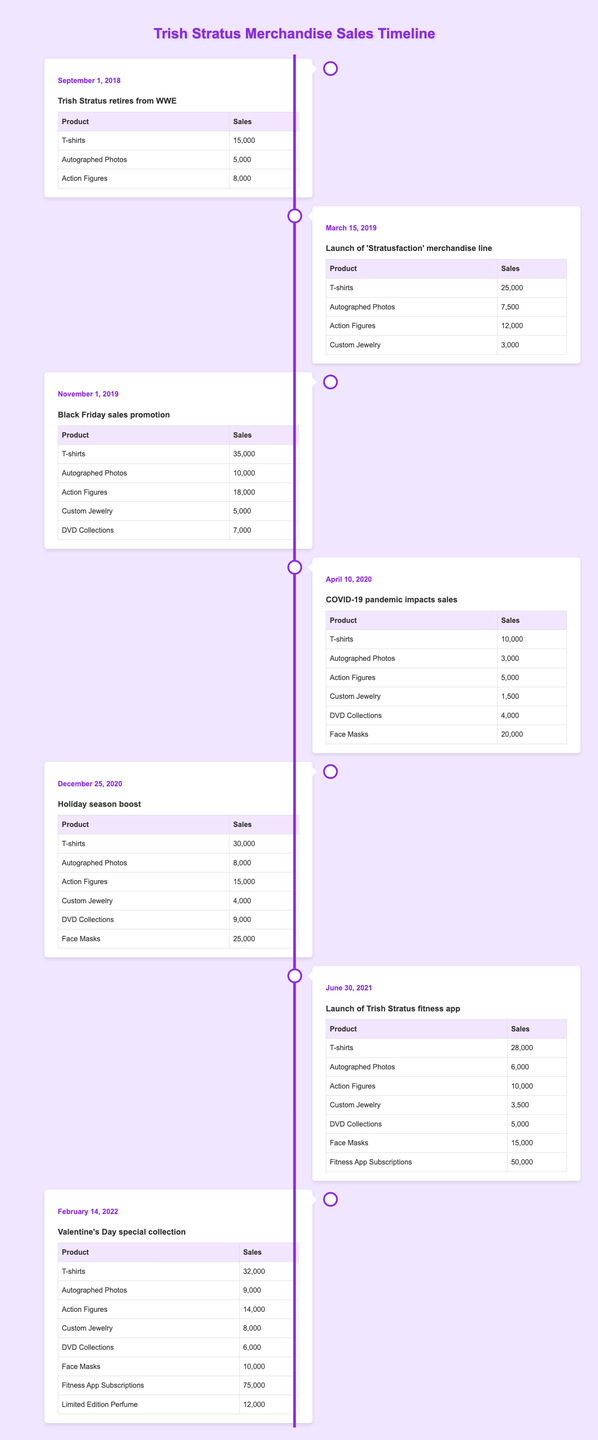What were the T-shirt sales on the launch of 'Stratusfaction' merchandise line? According to the table, on March 15, 2019, the T-shirt sales recorded were 25,000.
Answer: 25,000 What was the total number of action figures sold during the Black Friday sales promotion? From the table for November 1, 2019, action figure sales totaled 18,000.
Answer: 18,000 Did the sales of autographed photos increase from the time of retirement to the launch of 'Stratusfaction'? Comparing the sales, autographed photos sold 5,000 at retirement and 7,500 at the launch of 'Stratusfaction', which means sales did increase.
Answer: Yes What was the percentage increase in T-shirt sales from the launch of 'Stratusfaction' to the Black Friday sales promotion? The T-shirt sales increased from 25,000 to 35,000. The increase is 10,000. To calculate the percentage increase: (10,000 / 25,000) * 100 = 40%.
Answer: 40% What event had the highest sales of face masks? The table shows that on December 25, 2020, face masks sold 25,000, which is the highest number compared to other events.
Answer: Holiday season boost How many more custom jewelry items were sold during the Valentine's Day special collection compared to the COVID-19 pandemic sales? During the Valentine's Day special collection, 8,000 custom jewelry items were sold, while only 1,500 were sold during the COVID-19 pandemic impact. The difference is 8,000 - 1,500 = 6,500.
Answer: 6,500 Which event had the highest overall merchandise sales? To find this, we calculate total sales for each event. The Black Friday sales promotion on November 1, 2019 had total merchandise sales amounting to 35,000 + 10,000 + 18,000 + 5,000 + 7,000 = 75,000, which is the highest overall compared to other events.
Answer: Black Friday sales promotion How much did sales of the fitness app subscriptions increase from June 30, 2021, to February 14, 2022? On June 30, 2021, the fitness app subscriptions sold 50,000, and on February 14, 2022, it sold 75,000. The increase is 75,000 - 50,000 = 25,000.
Answer: 25,000 Did the addition of DVDs affect sales positively after the launch of 'Stratusfaction'? Comparing the total sales after each event, on the launch of 'Stratusfaction' (including DVDs: 25,000 + 7,500 + 12,000 + 3,000 = 47,500), whereas the Black Friday promotion total is 75,000 indicating a strong positive effect with the addition of DVDs to merchandise.
Answer: Yes 